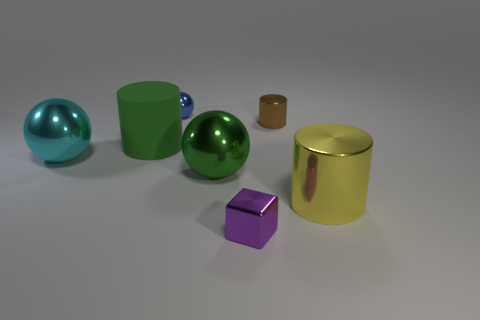There is a small brown metallic object on the left side of the yellow metal thing; is its shape the same as the tiny thing in front of the large yellow metal cylinder?
Keep it short and to the point. No. The small sphere that is the same material as the brown cylinder is what color?
Provide a short and direct response. Blue. There is a metal object behind the tiny brown cylinder; is it the same size as the cylinder left of the shiny cube?
Ensure brevity in your answer.  No. What shape is the metal thing that is behind the big green sphere and in front of the brown shiny cylinder?
Your answer should be very brief. Sphere. Is there a brown thing that has the same material as the tiny purple cube?
Make the answer very short. Yes. What is the material of the thing that is the same color as the big rubber cylinder?
Offer a very short reply. Metal. Do the tiny thing that is in front of the tiny metal cylinder and the small thing on the left side of the tiny purple thing have the same material?
Ensure brevity in your answer.  Yes. Is the number of green cylinders greater than the number of big metal spheres?
Offer a terse response. No. There is a metal ball to the right of the small thing on the left side of the small metal object in front of the large yellow cylinder; what color is it?
Your answer should be very brief. Green. Does the cylinder on the left side of the purple shiny object have the same color as the big sphere that is to the right of the small blue ball?
Offer a very short reply. Yes. 